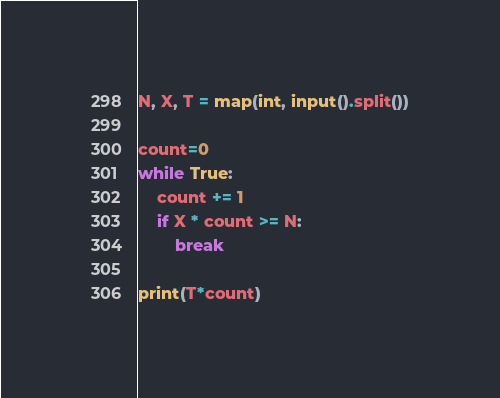Convert code to text. <code><loc_0><loc_0><loc_500><loc_500><_Python_>N, X, T = map(int, input().split())

count=0
while True:
    count += 1
    if X * count >= N:
        break
        
print(T*count)</code> 